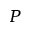Convert formula to latex. <formula><loc_0><loc_0><loc_500><loc_500>P</formula> 